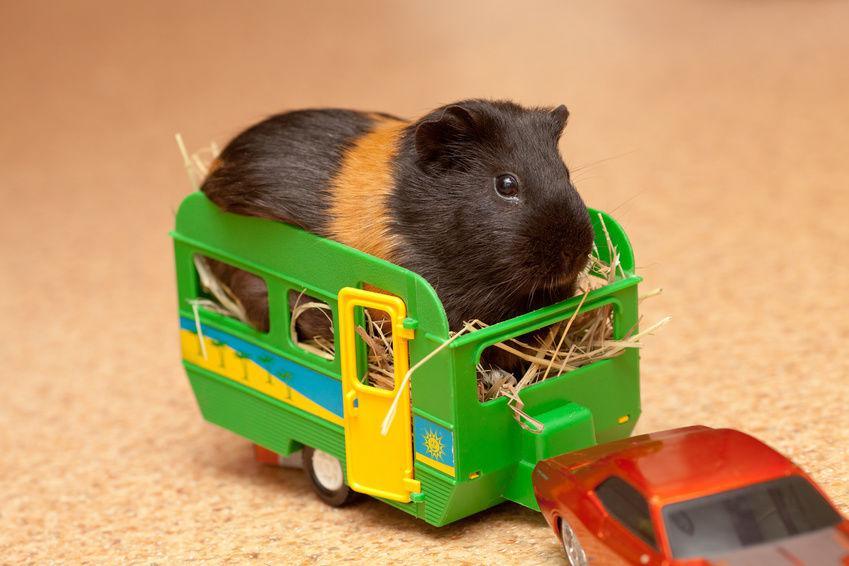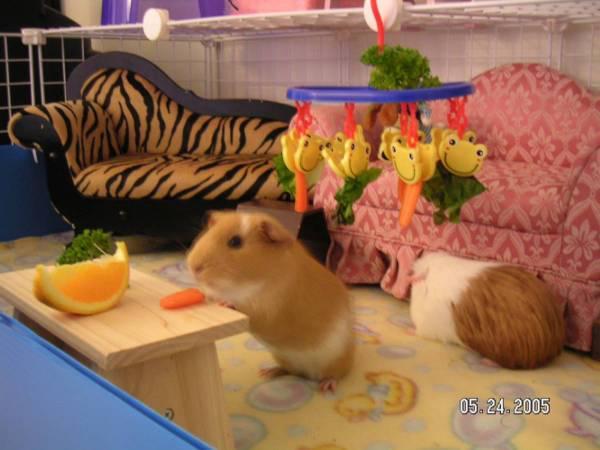The first image is the image on the left, the second image is the image on the right. Analyze the images presented: Is the assertion "At least one image has a backdrop using a white blanket with pink and black designs on it." valid? Answer yes or no. No. The first image is the image on the left, the second image is the image on the right. Analyze the images presented: Is the assertion "One image shows a single hamster under a semi-circular arch, and the other image includes a hamster in a wheeled wooden wagon." valid? Answer yes or no. No. 